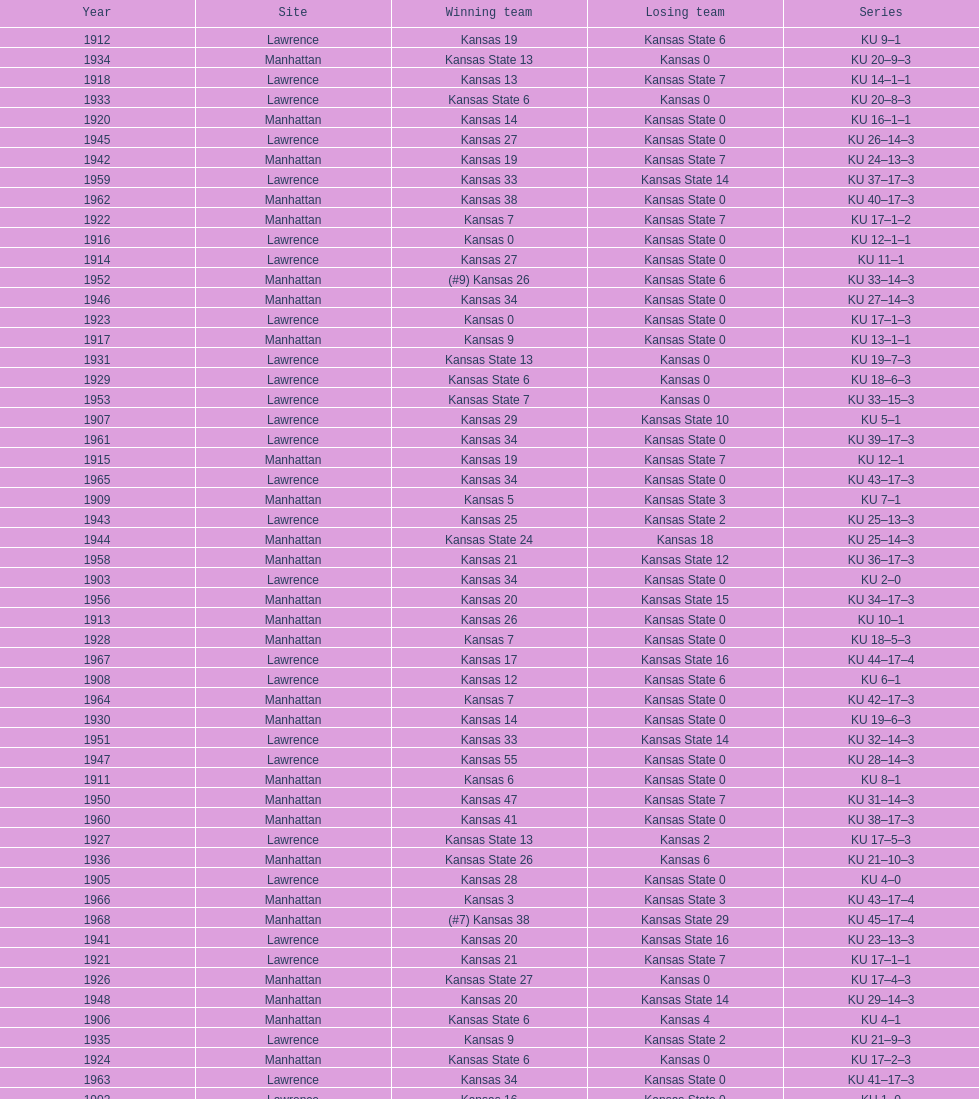How many times did kansas and kansas state play in lawrence from 1902-1968? 34. 